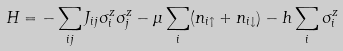Convert formula to latex. <formula><loc_0><loc_0><loc_500><loc_500>H = - \sum _ { i j } J _ { i j } \sigma _ { i } ^ { z } \sigma _ { j } ^ { z } - \mu \sum _ { i } ( n _ { i \uparrow } + n _ { i \downarrow } ) - h \sum _ { i } \sigma _ { i } ^ { z }</formula> 